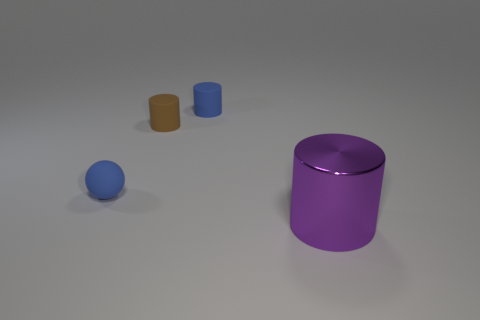Is there any other thing that is the same size as the shiny thing?
Give a very brief answer. No. Are there any other cylinders that have the same size as the brown cylinder?
Ensure brevity in your answer.  Yes. Is the number of big purple metallic things less than the number of small blue shiny blocks?
Provide a succinct answer. No. What shape is the small blue matte object to the right of the small object to the left of the tiny brown rubber cylinder that is behind the small blue sphere?
Your response must be concise. Cylinder. How many objects are either tiny rubber spheres that are in front of the brown cylinder or objects right of the small ball?
Offer a very short reply. 4. Are there any small matte things right of the brown cylinder?
Your response must be concise. Yes. How many objects are things that are behind the purple cylinder or tiny blue matte spheres?
Ensure brevity in your answer.  3. What number of gray objects are big metallic cylinders or small cylinders?
Make the answer very short. 0. What number of other things are there of the same color as the matte ball?
Keep it short and to the point. 1. Are there fewer small blue things on the left side of the small rubber ball than red cylinders?
Offer a terse response. No. 